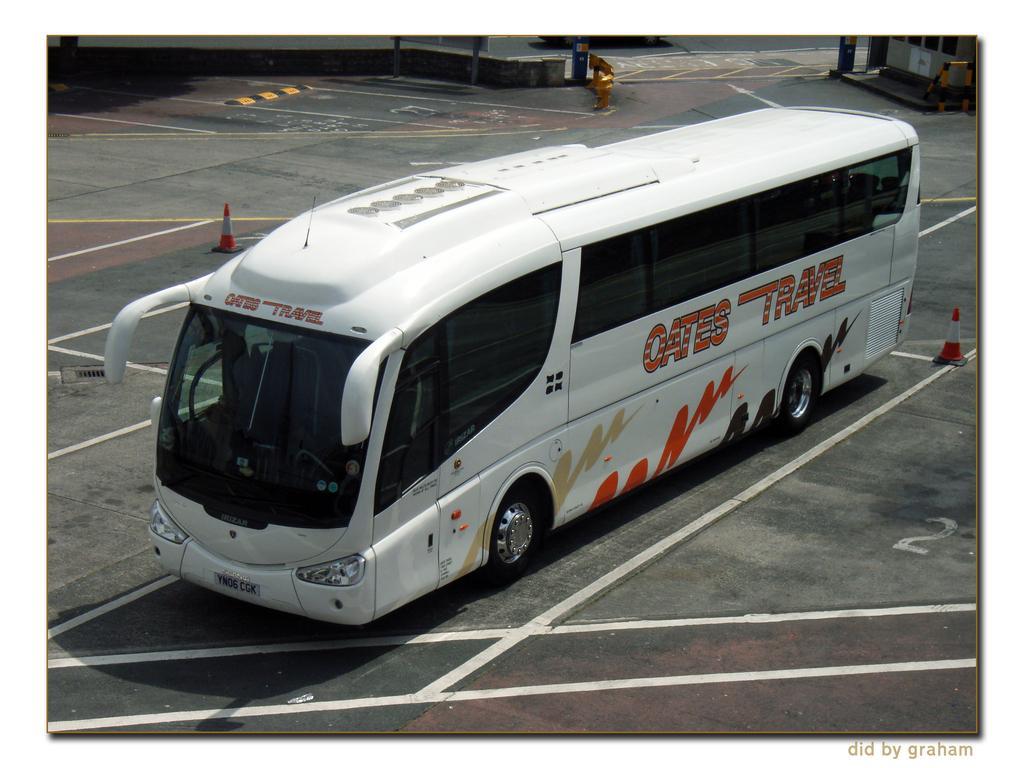Could you give a brief overview of what you see in this image? In this image we can see a bus parked in a parking lot. In the background, we can see a building two cones and a metal barricade. 